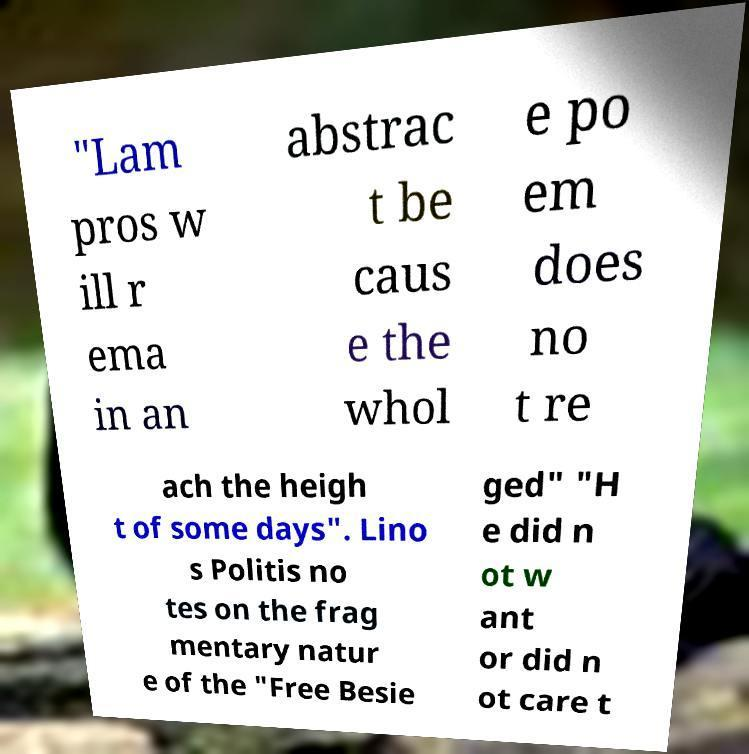What messages or text are displayed in this image? I need them in a readable, typed format. "Lam pros w ill r ema in an abstrac t be caus e the whol e po em does no t re ach the heigh t of some days". Lino s Politis no tes on the frag mentary natur e of the "Free Besie ged" "H e did n ot w ant or did n ot care t 